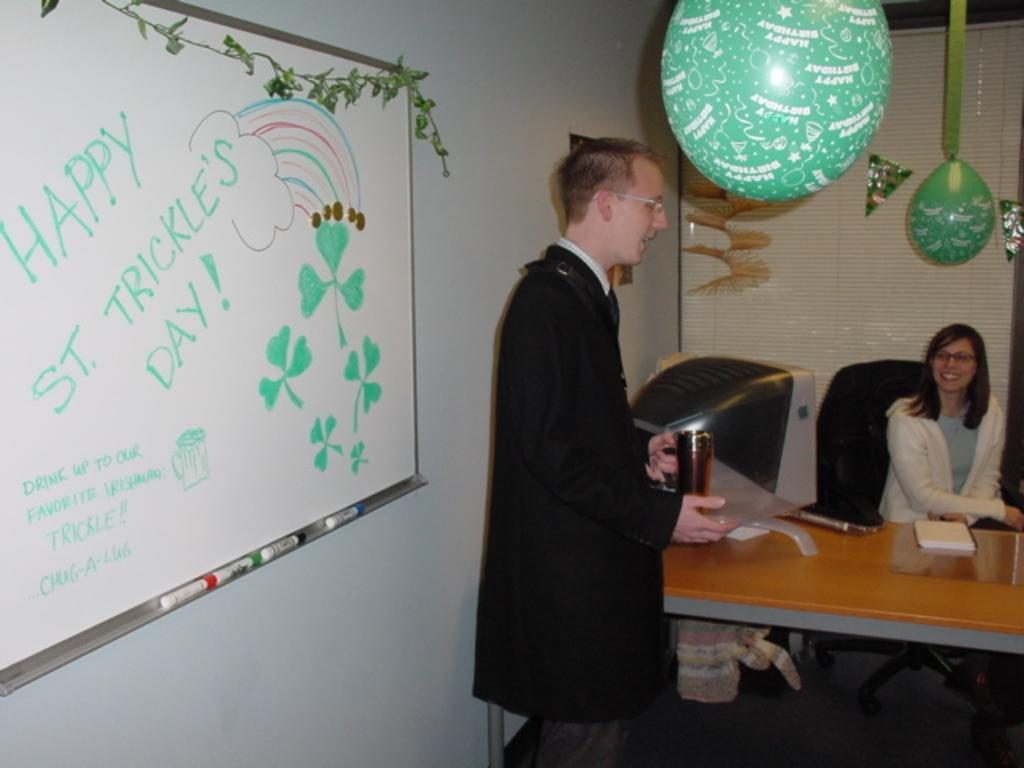Who or what is in the image? There is a person in the image. What is the person doing or standing in front of? The person is standing in front of a board. Are there any additional elements visible in the image? Yes, there are balloons on the roof. What type of debt is the person discussing with the writer in the image? There is no writer or discussion of debt present in the image. 